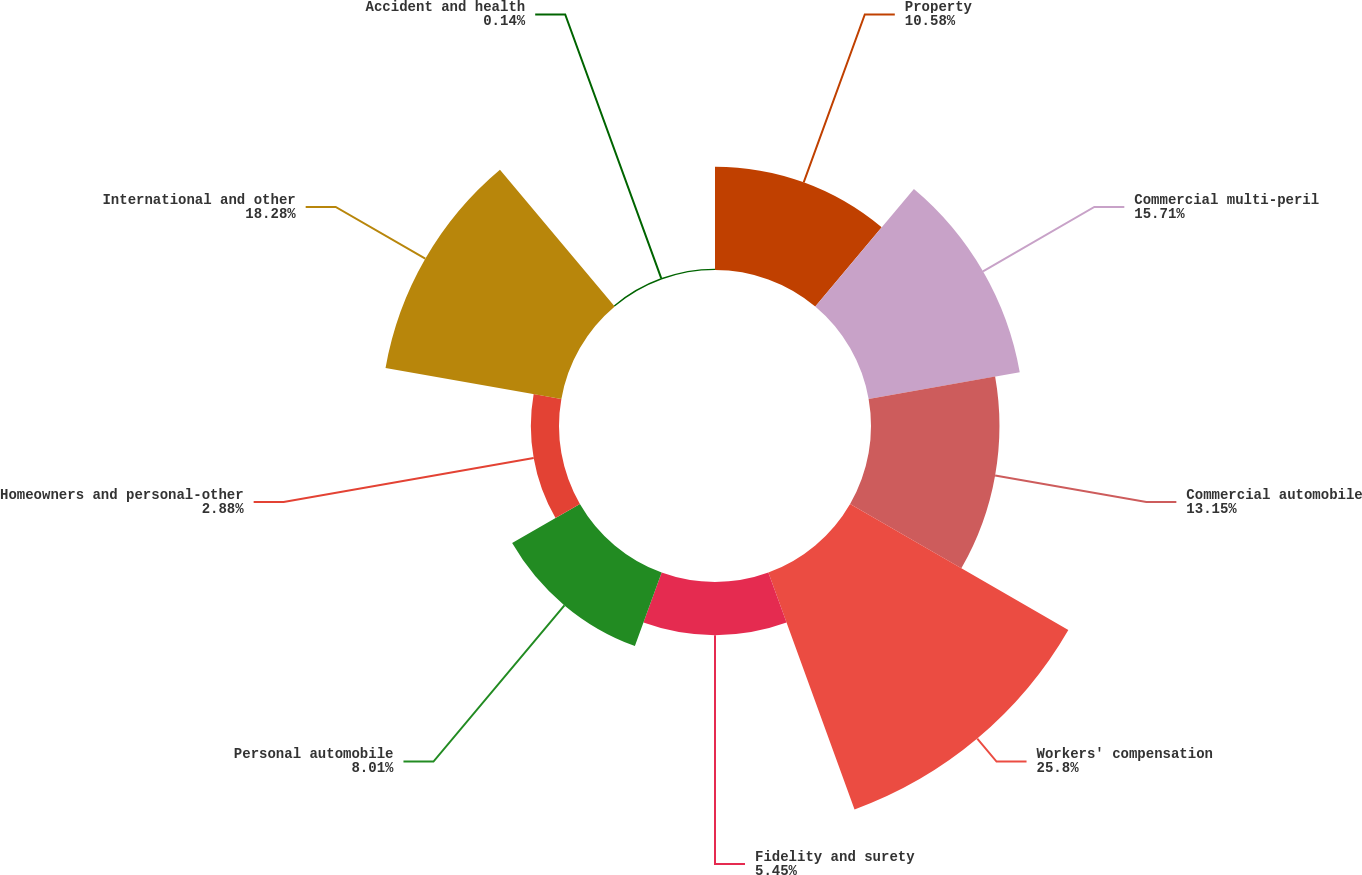<chart> <loc_0><loc_0><loc_500><loc_500><pie_chart><fcel>Property<fcel>Commercial multi-peril<fcel>Commercial automobile<fcel>Workers' compensation<fcel>Fidelity and surety<fcel>Personal automobile<fcel>Homeowners and personal-other<fcel>International and other<fcel>Accident and health<nl><fcel>10.58%<fcel>15.71%<fcel>13.15%<fcel>25.8%<fcel>5.45%<fcel>8.01%<fcel>2.88%<fcel>18.28%<fcel>0.14%<nl></chart> 